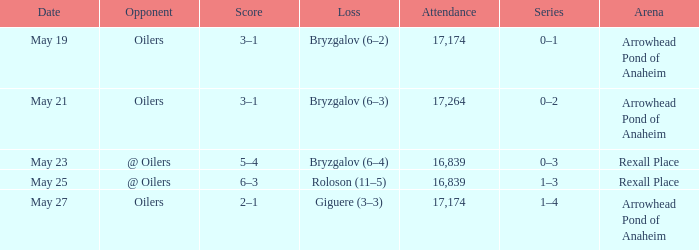What was the attendance on may 21? 17264.0. 